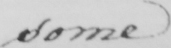Can you tell me what this handwritten text says? some 